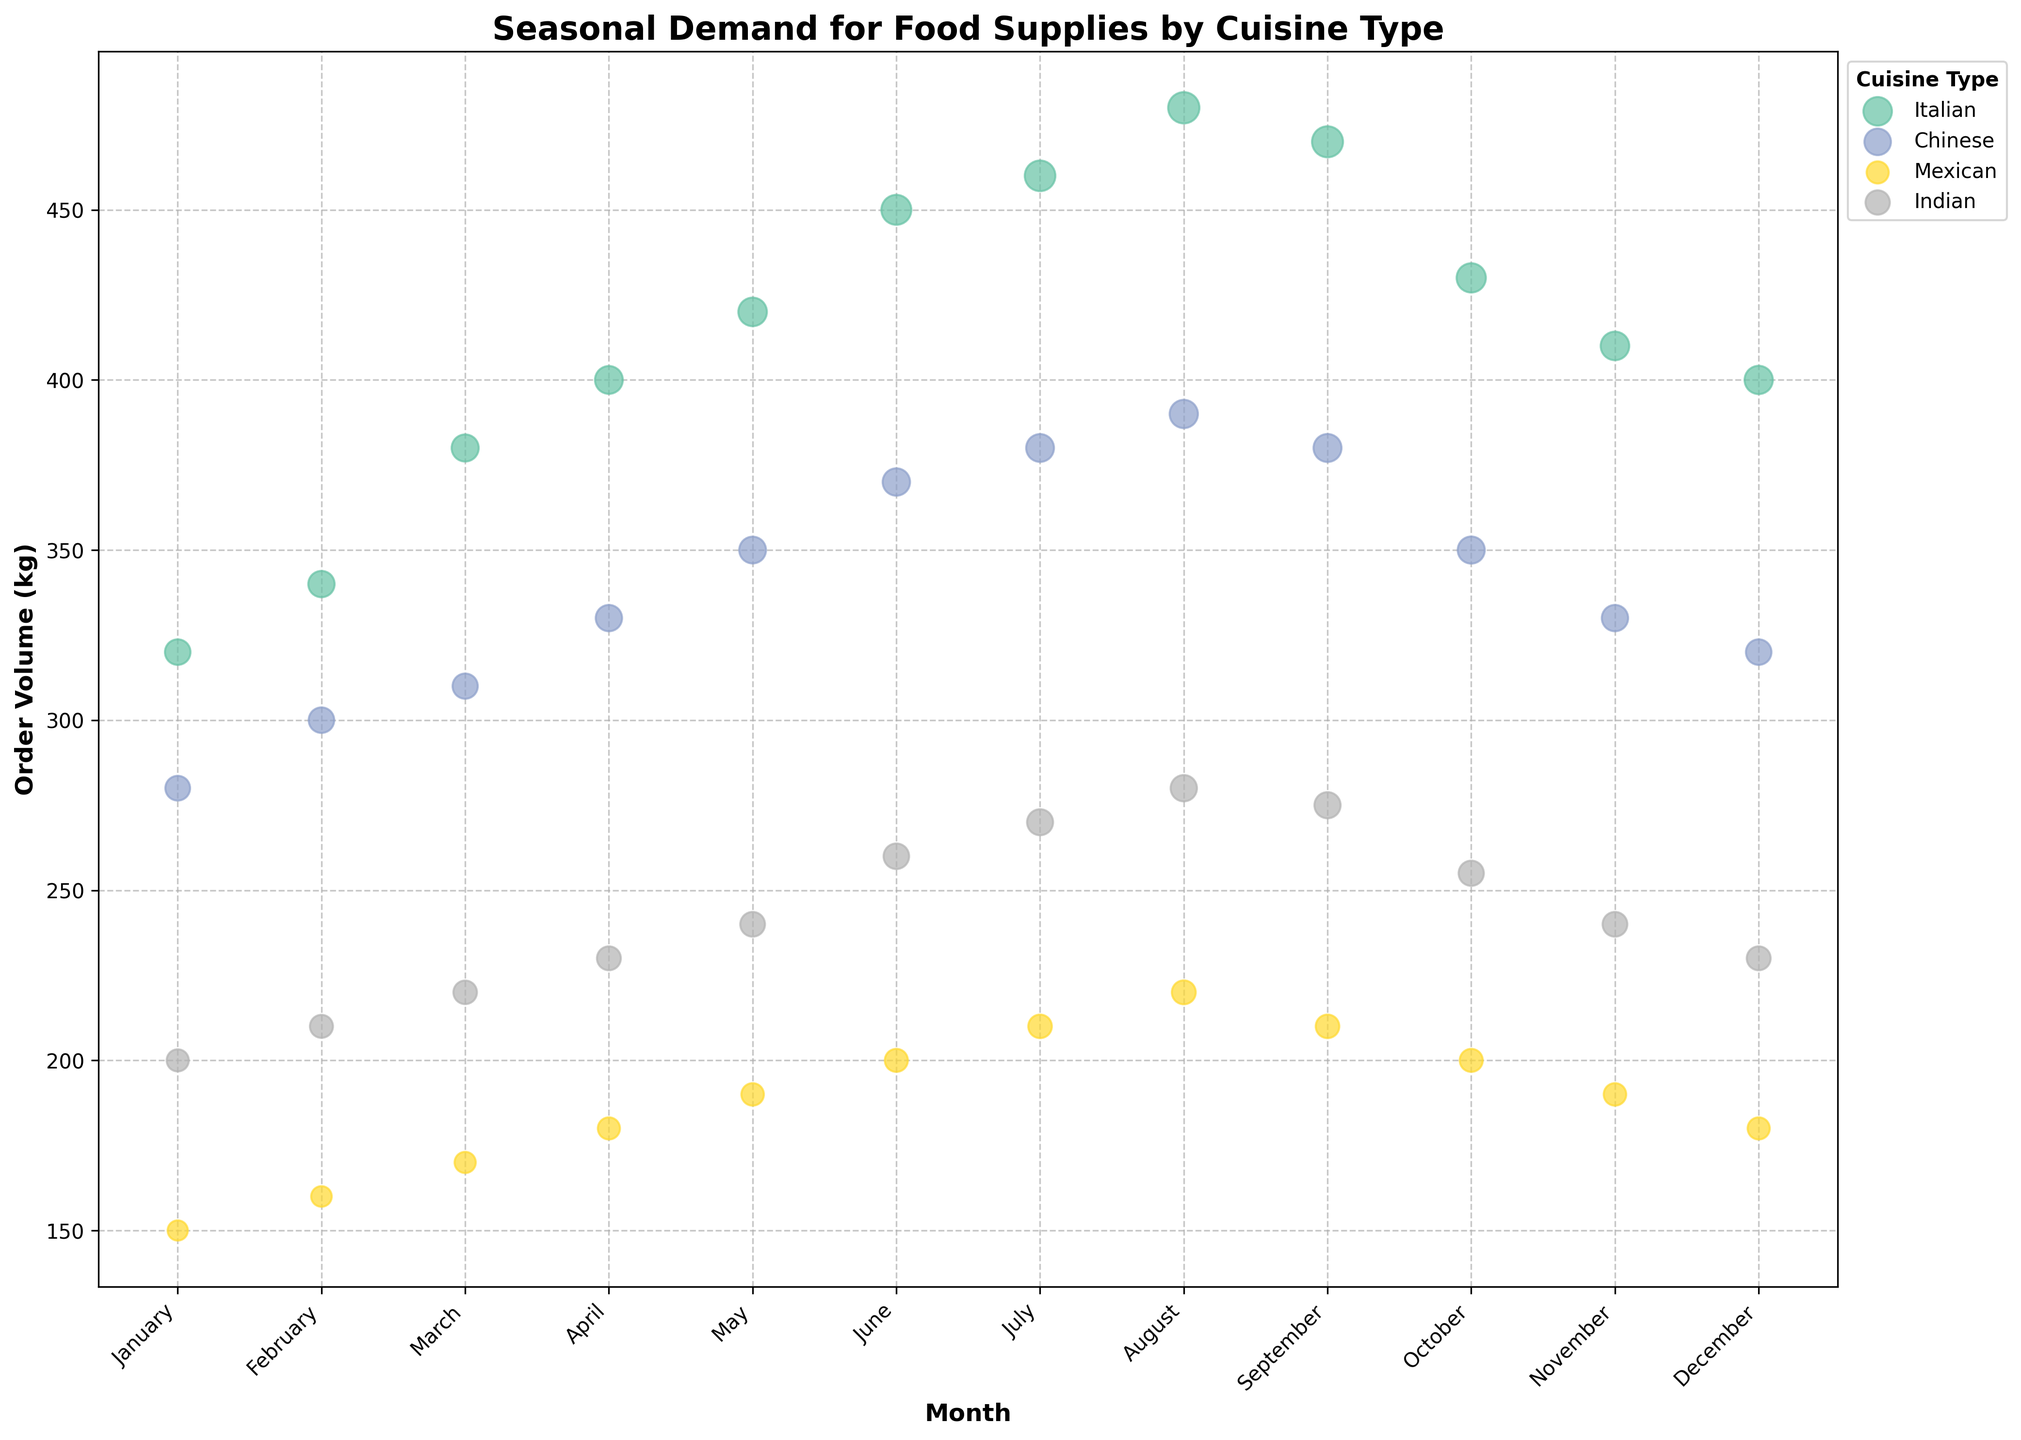What's the title of the figure? The title of the figure is usually located at the top of the chart. In this case, it reads "Seasonal Demand for Food Supplies by Cuisine Type".
Answer: Seasonal Demand for Food Supplies by Cuisine Type Which month shows the highest order volume for Chinese cuisine? To find this, look at the y-axis for the Chinese cuisine data points and identify which month has the highest y-coordinate. August shows the highest order volume.
Answer: August What cuisine type has the largest bubble in July? The size of the bubble indicates the number of orders. In July, compare the bubble sizes for all cuisines. The Italian cuisine has the largest bubble, indicating the highest number of orders.
Answer: Italian How does the order volume for Mexican cuisine in December compare to January? Check the y-coordinates of the Mexican cuisine data points in December and January. Both points are at the same y-coordinate, so the volume is the same in both months.
Answer: Same What is the general trend for order volumes for Italian cuisine from January to August? Observe the Italian cuisine data points from January to August. The y-coordinates generally increase, indicating that the order volume rises over these months.
Answer: Increasing Which month has the smallest bubble size for Indian cuisine? The bubble size represents the number of orders. By comparing the sizes, January has the smallest bubble for Indian cuisine.
Answer: January What is the difference in order volume between Italian and Chinese cuisines in June? Locate the y-coordinates for Italian and Chinese cuisines in June. The order volume for Italian is 450 kg and for Chinese is 370 kg. The difference is 450 - 370.
Answer: 80 kg Which cuisine types have an increasing trend in order volume from January to June? Identify the cuisine points and their y-coordinates from January to June. Both Italian and Indian cuisines show an increasing trend in order volumes.
Answer: Italian and Indian What are the x and y-axis labels? The labels for the axes are found next to the axes themselves. The x-axis is labeled "Month" and the y-axis is labeled "Order Volume (kg)".
Answer: Month (x-axis), Order Volume (kg) (y-axis) Is there any month where all cuisine types have equal order volumes? Compare the y-coordinates of all data points in each month. There is no month where all cuisine types have equal order volumes.
Answer: No 